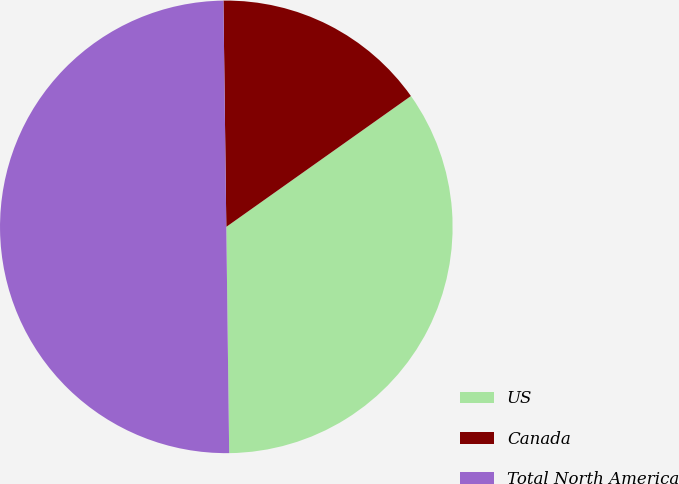<chart> <loc_0><loc_0><loc_500><loc_500><pie_chart><fcel>US<fcel>Canada<fcel>Total North America<nl><fcel>34.61%<fcel>15.39%<fcel>50.0%<nl></chart> 